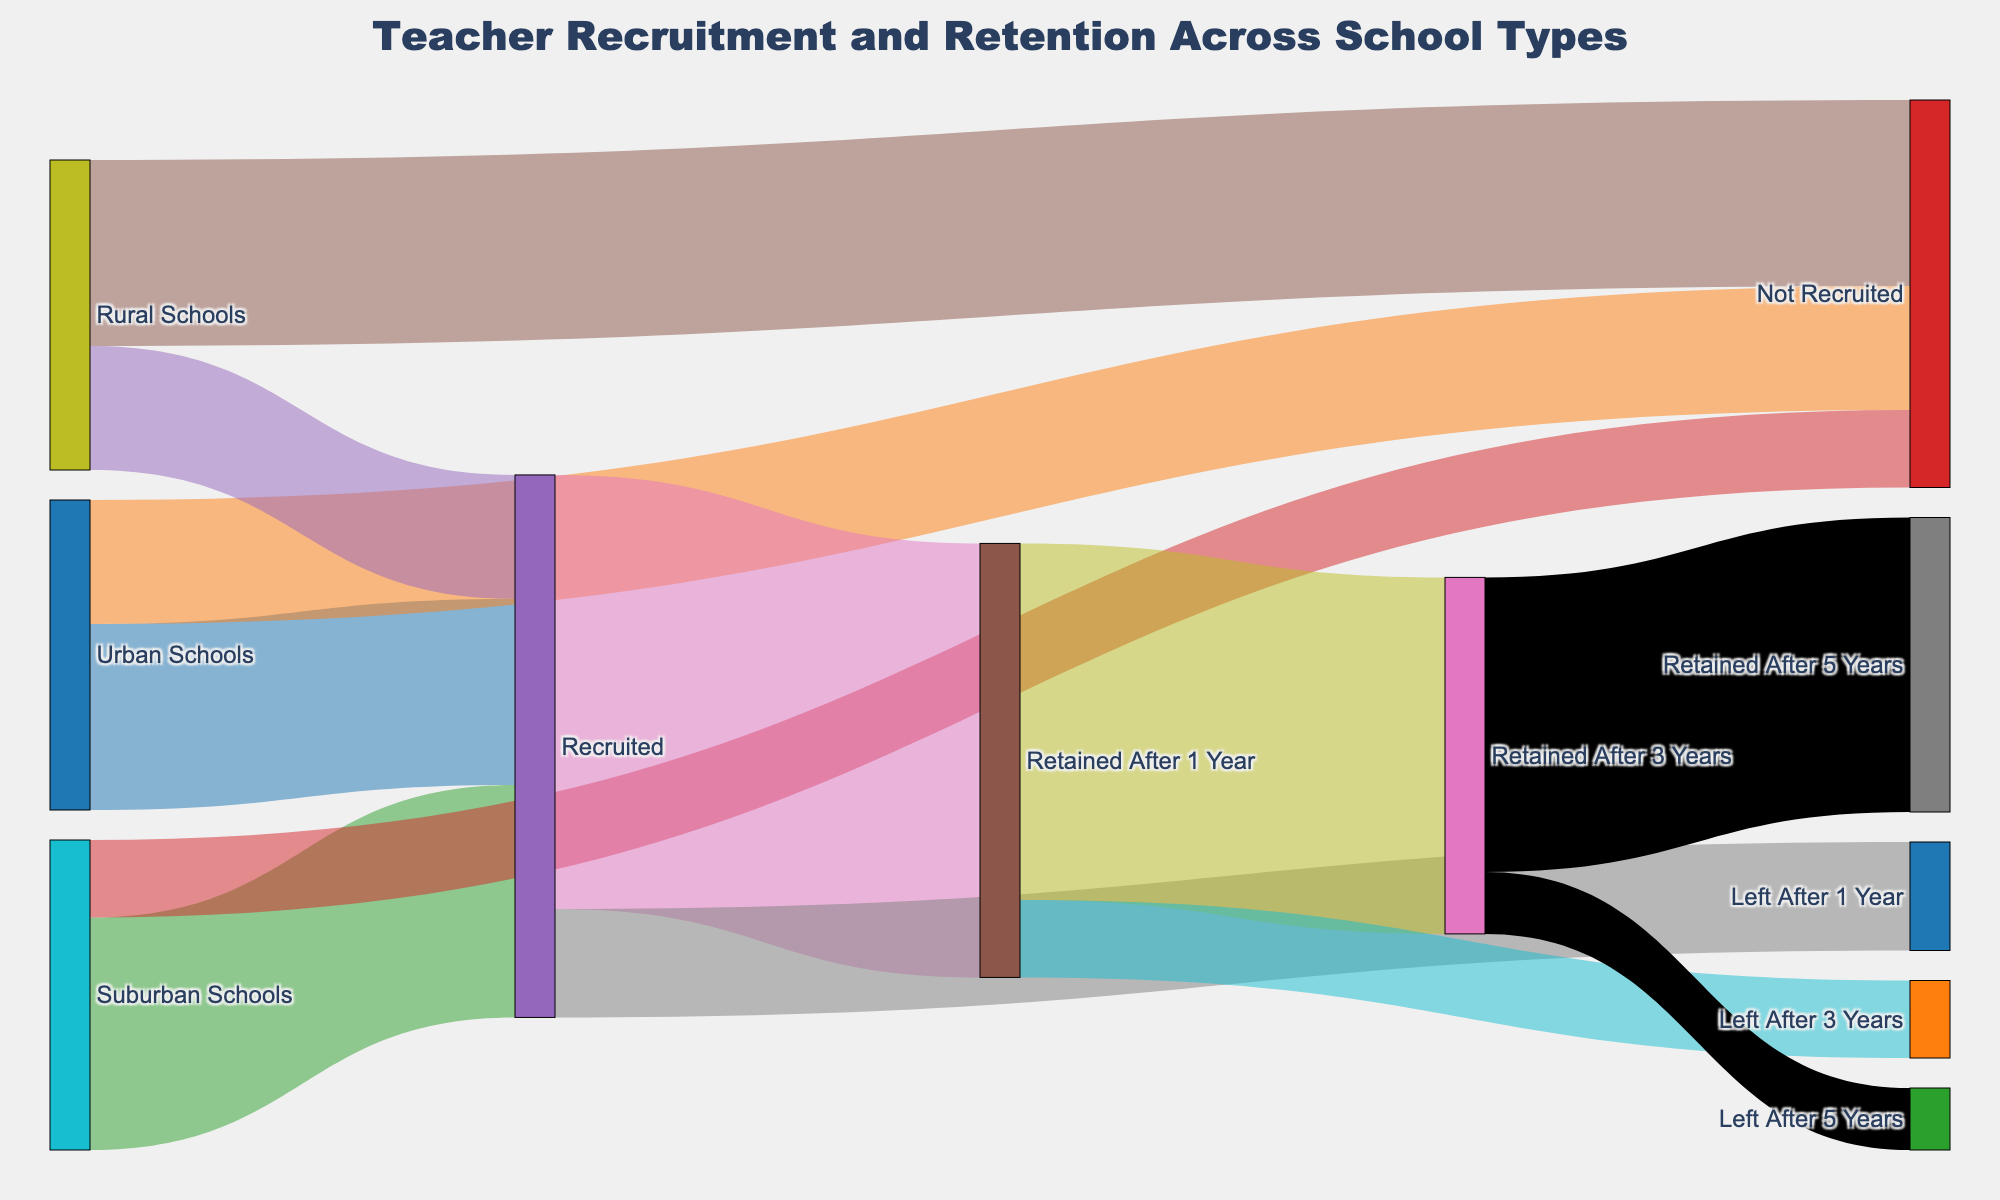What is the title of the figure? The title is located at the top center of the figure and reads "Teacher Recruitment and Retention Across School Types".
Answer: Teacher Recruitment and Retention Across School Types How many teachers were recruited in urban schools? The flow coming from "Urban Schools" to "Recruited" indicates that 1200 teachers were recruited.
Answer: 1200 How many teachers left after 1 year? The flow going from "Recruited" to "Left After 1 Year" contains 700 teachers.
Answer: 700 How many teachers were retained for 3 years or more? To determine this, you sum the flows from "Retained After 1 Year" to "Retained After 3 Years" and then look at "Retained After 3 Years" to "Retained After 5 Years". So, it's 2300 + 1900.
Answer: 4200 Which school type had the lowest recruitment rate? The thickness of the flows from each school type to the "Recruited" target shows that Rural Schools have the smallest flow, with a value of 800.
Answer: Rural Schools What percentage of recruited teachers from suburban schools were retained after 5 years? First, find the number of teachers from suburban schools recruited, which is 1500. Then, trace these teachers through the flows: (1500 / 1500) * (2800 / 2800) * (2300 / 2300) * (1900 / 2300) * 100 = 1900 / 1500 * 100 = 126.67 / 10 = 21.67%.
Answer: 21.67% Which flow represents the highest number of teachers? The largest flow is from "Recruited" to "Retained After 1 Year" with 2800 teachers.
Answer: Recruited to Retained After 1 Year What is the total number of teachers that were not recruited across all school types? Sum the flows from each school type to "Not Recruited": 800 (Urban) + 500 (Suburban) + 1200 (Rural) = 2500.
Answer: 2500 Are more teachers retained after 3 years or left after 3 years? The flow from "Retained After 1 Year" to "Retained After 3 Years" is 2300, while the flow from "Retained After 1 Year" to "Left After 3 Years" is 500. Since 2300 is greater than 500, more teachers are retained.
Answer: Retained after 3 years 